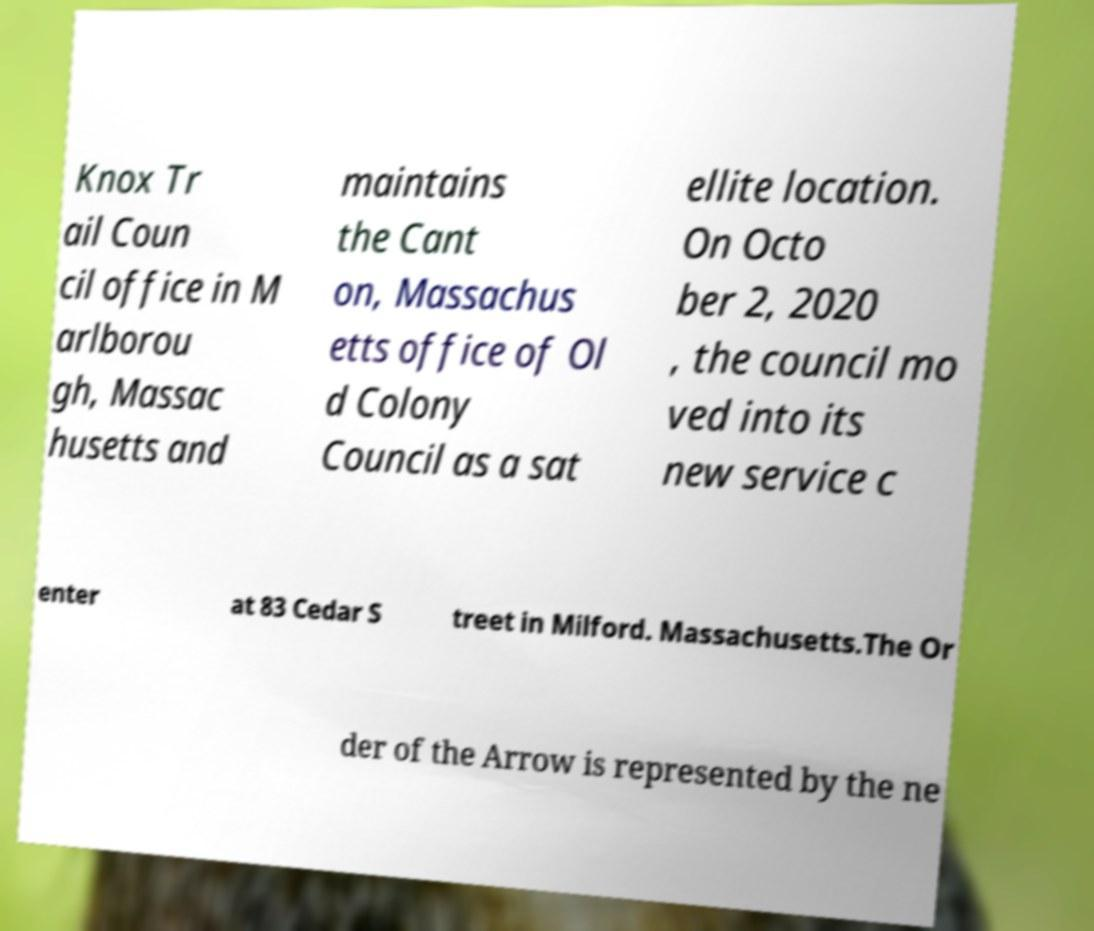Can you accurately transcribe the text from the provided image for me? Knox Tr ail Coun cil office in M arlborou gh, Massac husetts and maintains the Cant on, Massachus etts office of Ol d Colony Council as a sat ellite location. On Octo ber 2, 2020 , the council mo ved into its new service c enter at 83 Cedar S treet in Milford. Massachusetts.The Or der of the Arrow is represented by the ne 